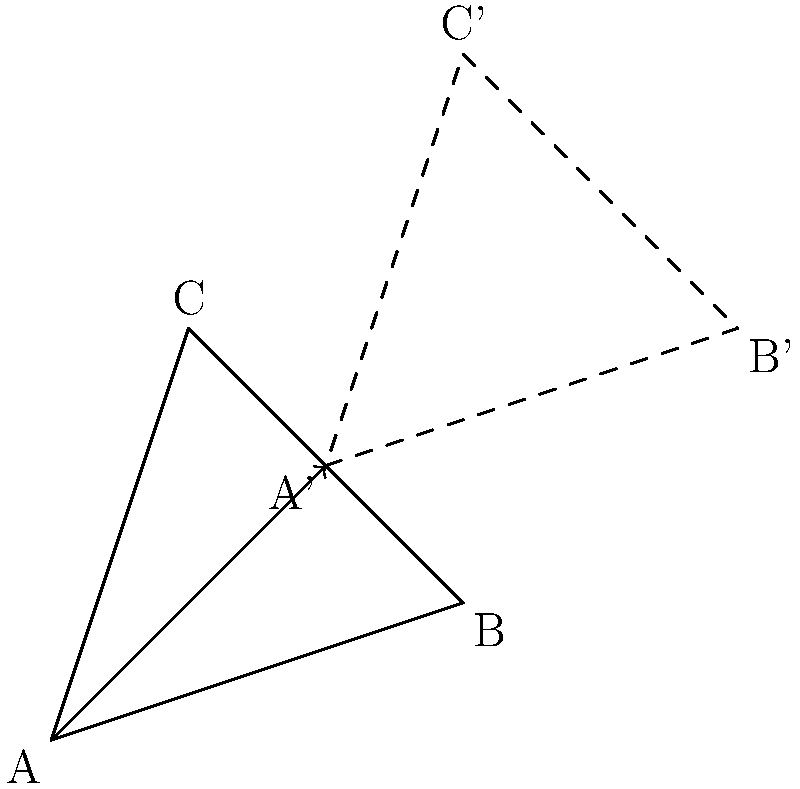In translating a constellation chart from an ancient astronomical text to match current night sky positions, you've determined that the entire chart needs to be shifted by 2 units right and 2 units up. Given the original triangle ABC representing a constellation, what is the transformation matrix T that would correctly translate the constellation to its new position A'B'C'? To solve this problem, let's follow these steps:

1) In a 2D translation, we add a constant to each coordinate. The general form of a translation matrix is:

   $$T = \begin{bmatrix} 1 & 0 & t_x \\ 0 & 1 & t_y \\ 0 & 0 & 1 \end{bmatrix}$$

   where $t_x$ is the horizontal translation and $t_y$ is the vertical translation.

2) In this case, we're translating 2 units right ($t_x = 2$) and 2 units up ($t_y = 2$).

3) Substituting these values into our general translation matrix:

   $$T = \begin{bmatrix} 1 & 0 & 2 \\ 0 & 1 & 2 \\ 0 & 0 & 1 \end{bmatrix}$$

4) This matrix, when applied to any point $(x, y)$ in the original constellation, will transform it to its new position $(x', y')$:

   $$\begin{bmatrix} x' \\ y' \\ 1 \end{bmatrix} = \begin{bmatrix} 1 & 0 & 2 \\ 0 & 1 & 2 \\ 0 & 0 & 1 \end{bmatrix} \begin{bmatrix} x \\ y \\ 1 \end{bmatrix}$$

5) This results in:
   $x' = x + 2$
   $y' = y + 2$

   Which correctly translates each point 2 units right and 2 units up.
Answer: $$\begin{bmatrix} 1 & 0 & 2 \\ 0 & 1 & 2 \\ 0 & 0 & 1 \end{bmatrix}$$ 